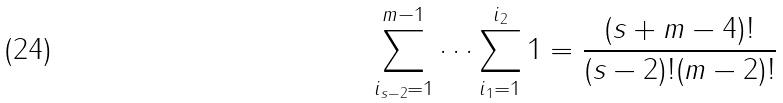Convert formula to latex. <formula><loc_0><loc_0><loc_500><loc_500>\sum _ { i _ { s - 2 } = 1 } ^ { m - 1 } \dots \sum _ { i _ { 1 } = 1 } ^ { i _ { 2 } } 1 = \frac { ( s + m - 4 ) ! } { ( s - 2 ) ! ( m - 2 ) ! }</formula> 